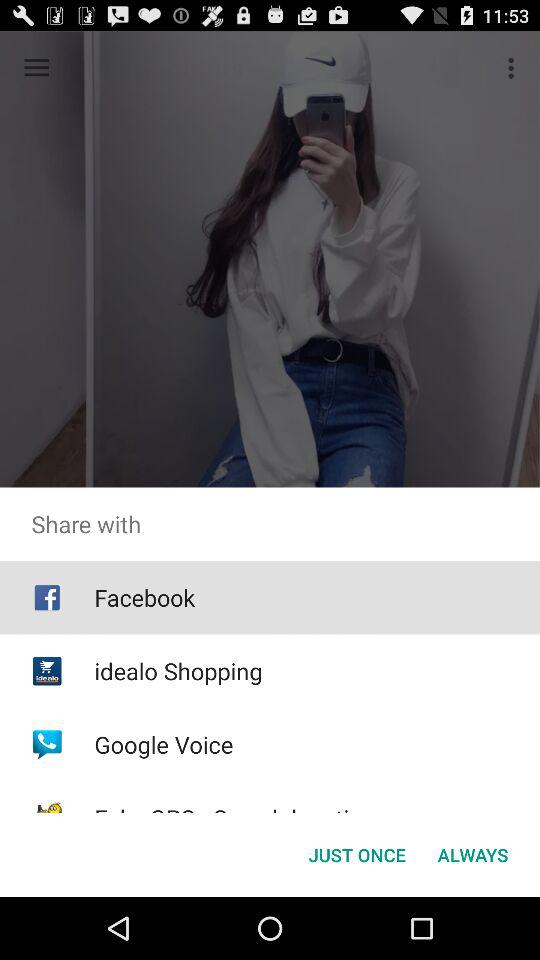Which applications can be used to share? The applications "Facebook", "idealo Shopping" and "Google Voice" can be used to share. 